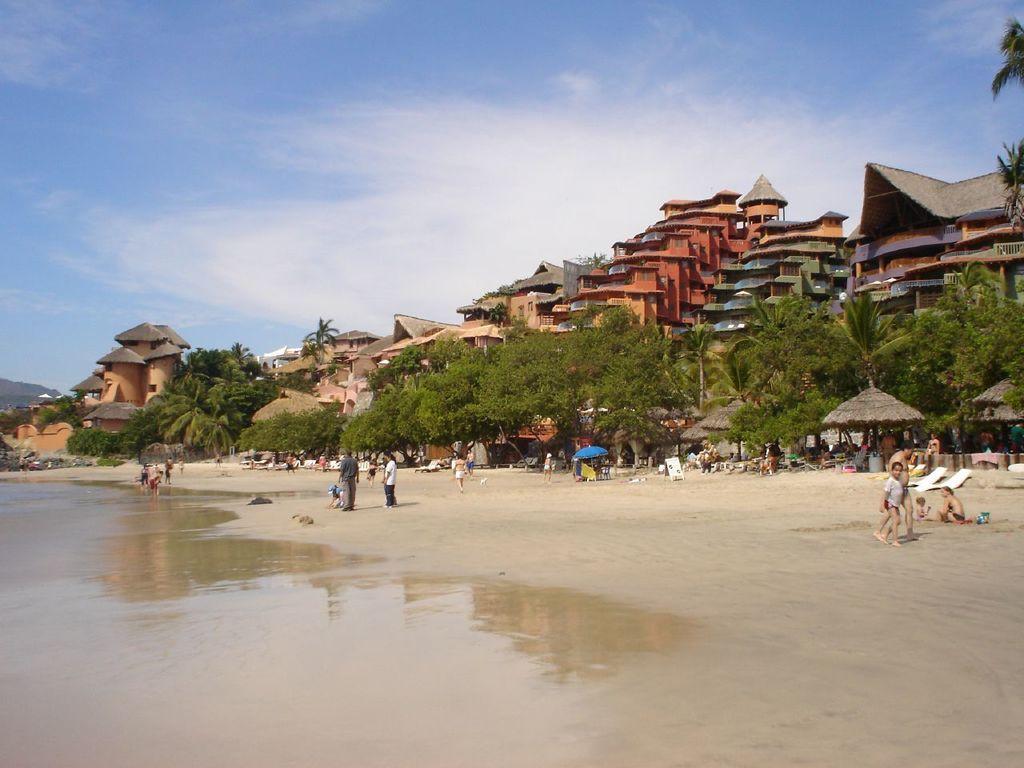How would you summarize this image in a sentence or two? In this picture there are people and we can see water, sand, huts, board, trees, buildings, umbrella and objects. In the background of the image we can see the sky. 